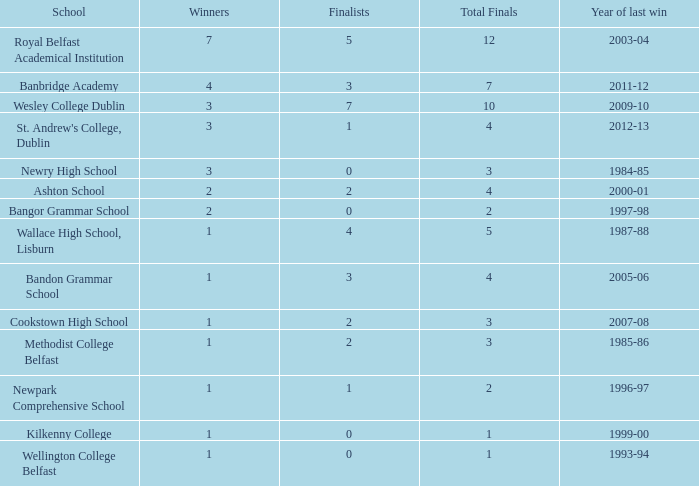Which school had its most recent victory in the 1985-86 school year? Methodist College Belfast. 